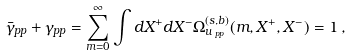Convert formula to latex. <formula><loc_0><loc_0><loc_500><loc_500>\bar { \gamma } _ { p p } + \gamma _ { p p } = \sum _ { m = 0 } ^ { \infty } \int d X ^ { + } d X ^ { - } \Omega _ { u \, _ { p p } } ^ { ( s , b ) } ( m , X ^ { + } , X ^ { - } ) = 1 \, ,</formula> 